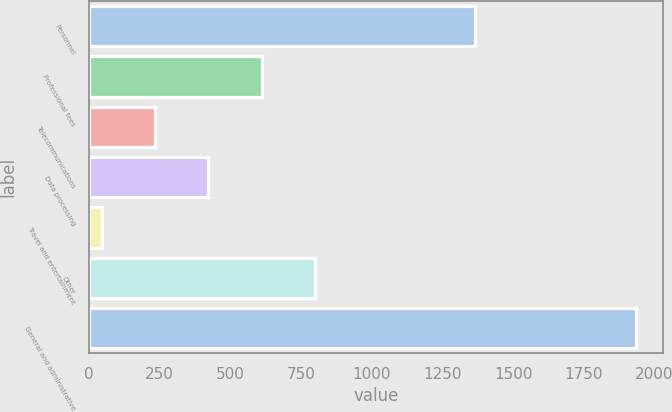Convert chart. <chart><loc_0><loc_0><loc_500><loc_500><bar_chart><fcel>Personnel<fcel>Professional fees<fcel>Telecommunications<fcel>Data processing<fcel>Travel and entertainment<fcel>Other<fcel>General and administrative<nl><fcel>1365<fcel>611.3<fcel>233.1<fcel>422.2<fcel>44<fcel>800.4<fcel>1935<nl></chart> 